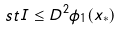<formula> <loc_0><loc_0><loc_500><loc_500>s t I \leq D ^ { 2 } \phi _ { 1 } ( x _ { * } )</formula> 